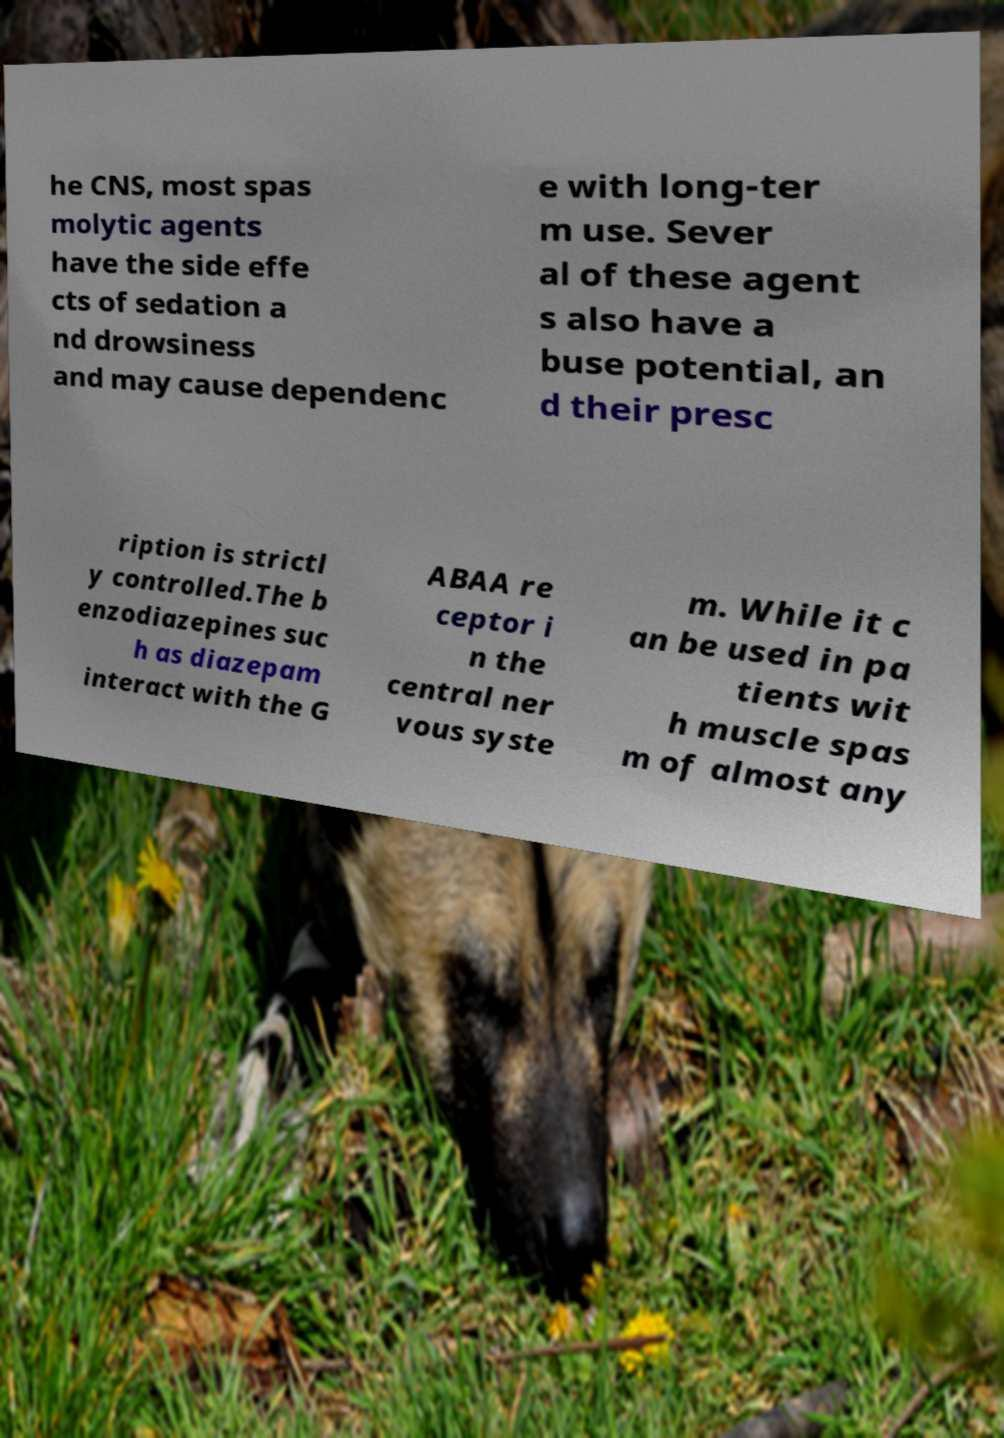Can you accurately transcribe the text from the provided image for me? he CNS, most spas molytic agents have the side effe cts of sedation a nd drowsiness and may cause dependenc e with long-ter m use. Sever al of these agent s also have a buse potential, an d their presc ription is strictl y controlled.The b enzodiazepines suc h as diazepam interact with the G ABAA re ceptor i n the central ner vous syste m. While it c an be used in pa tients wit h muscle spas m of almost any 